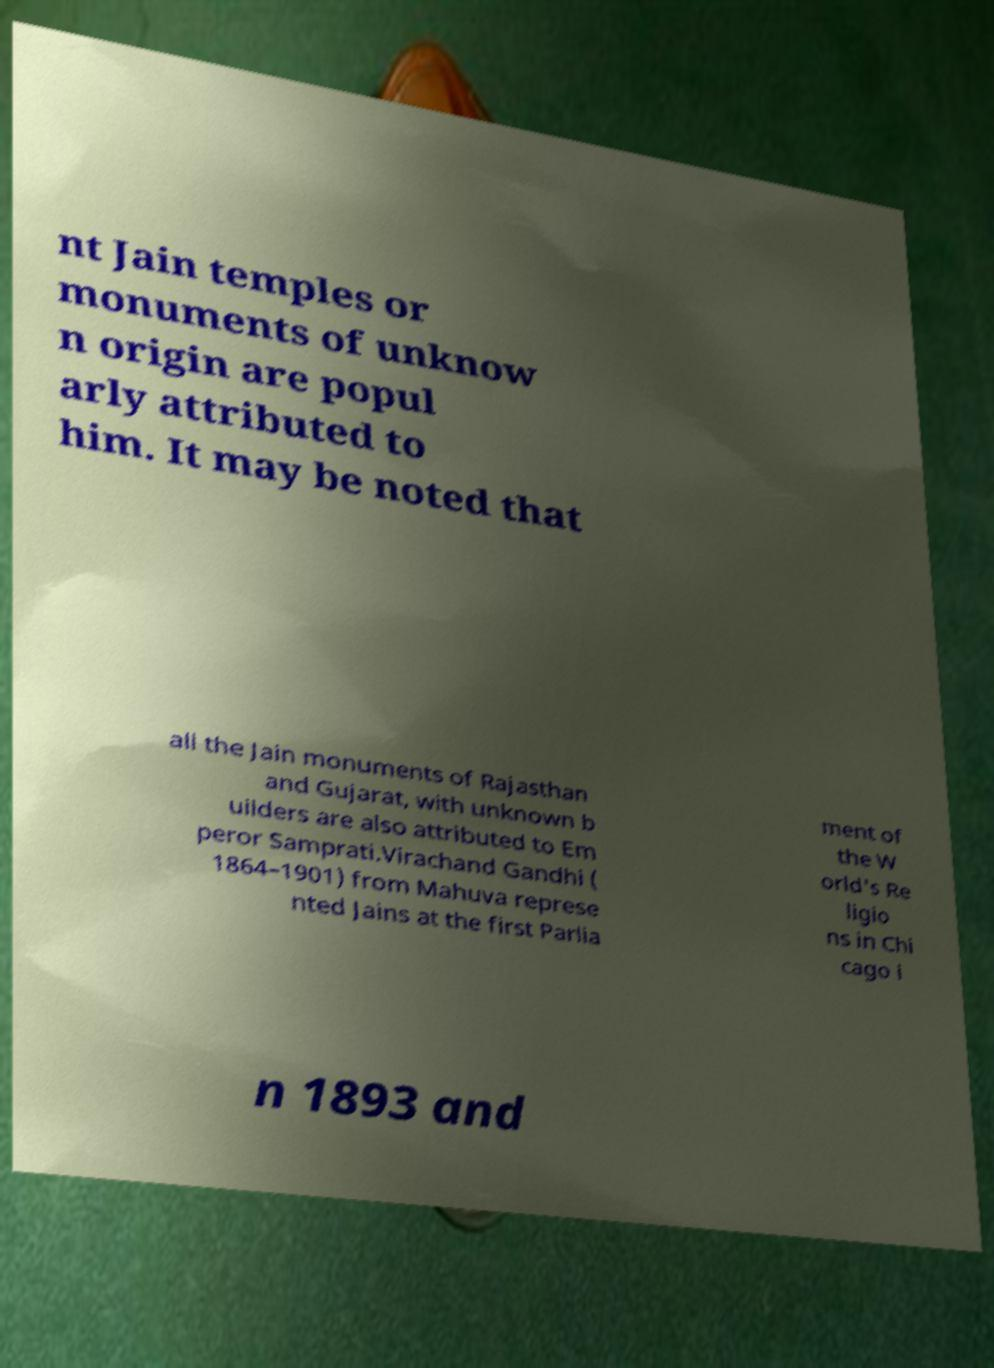Could you extract and type out the text from this image? nt Jain temples or monuments of unknow n origin are popul arly attributed to him. It may be noted that all the Jain monuments of Rajasthan and Gujarat, with unknown b uilders are also attributed to Em peror Samprati.Virachand Gandhi ( 1864–1901) from Mahuva represe nted Jains at the first Parlia ment of the W orld's Re ligio ns in Chi cago i n 1893 and 